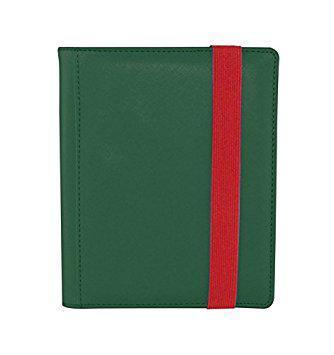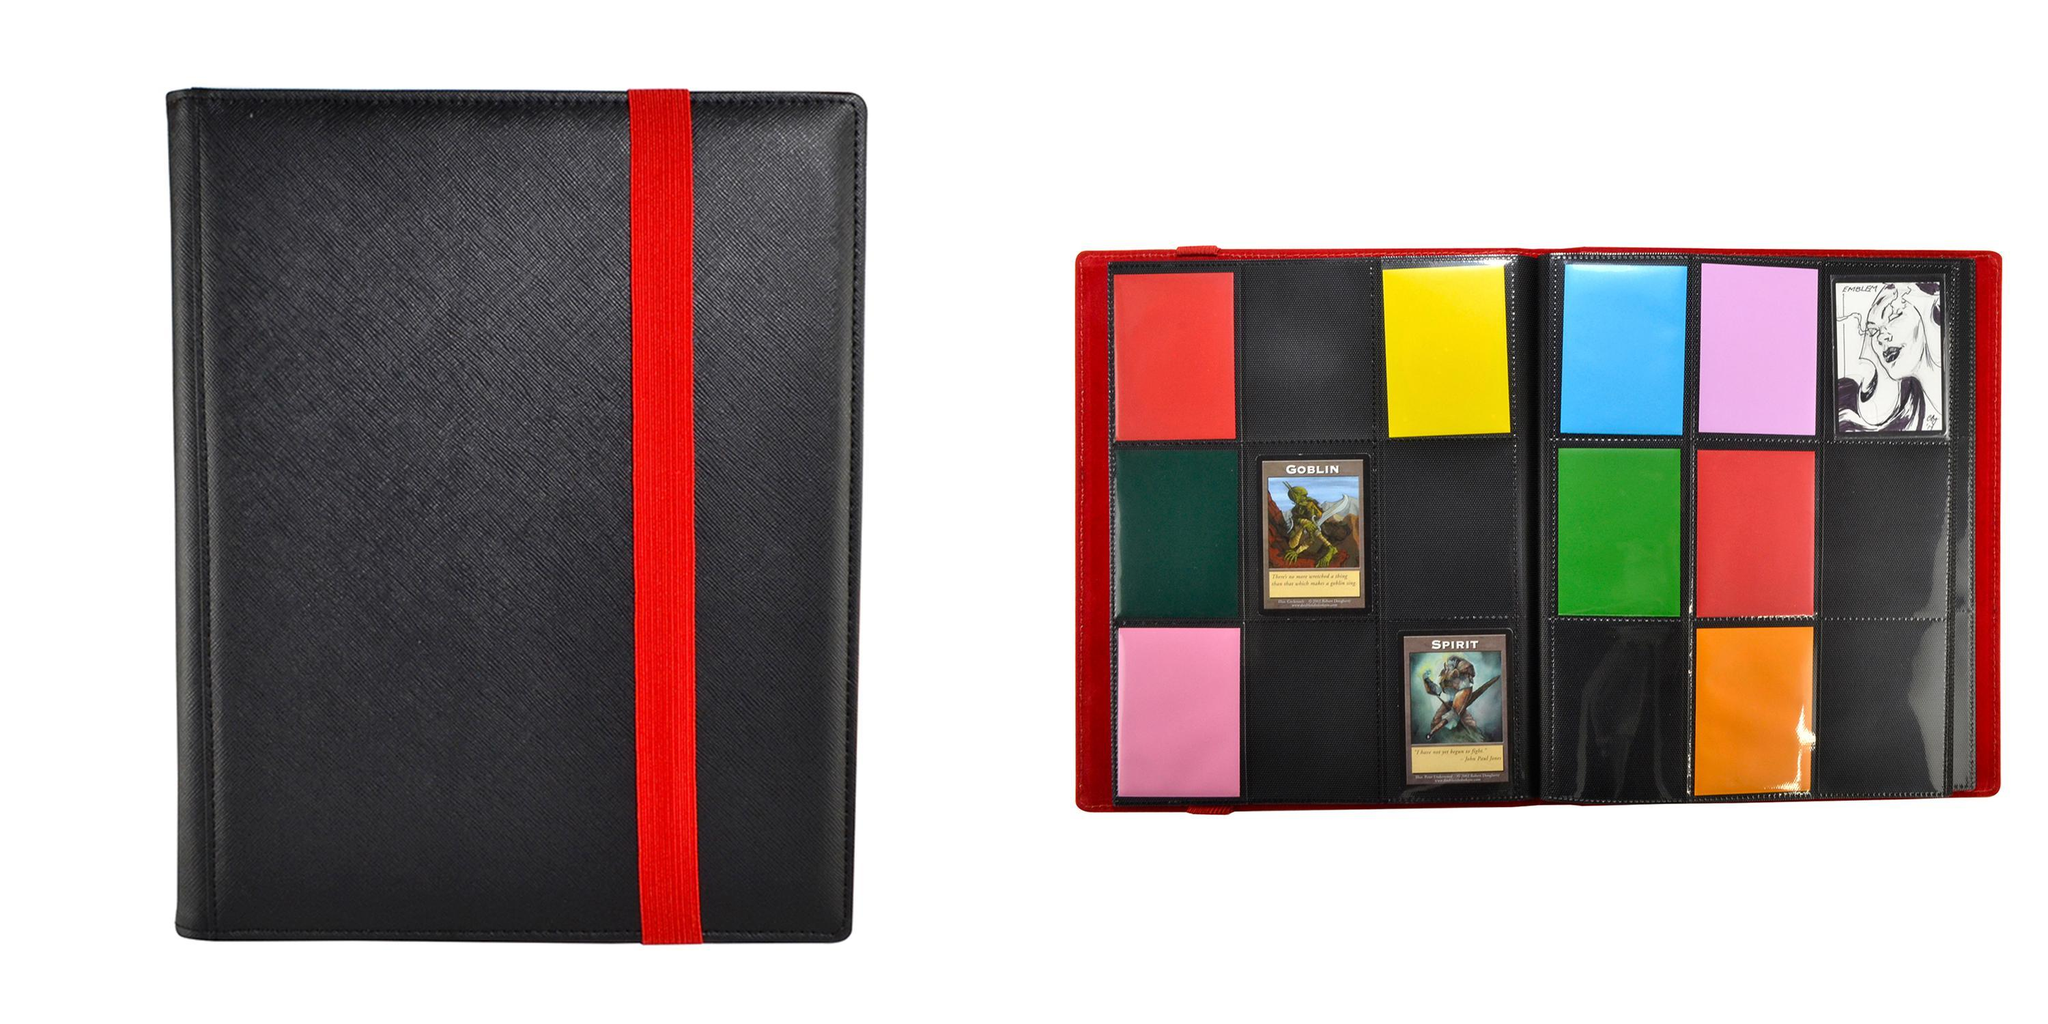The first image is the image on the left, the second image is the image on the right. For the images shown, is this caption "In one image, a black album with red trim is show both open and closed." true? Answer yes or no. Yes. 